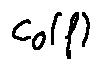<formula> <loc_0><loc_0><loc_500><loc_500>c _ { 0 } ( f )</formula> 